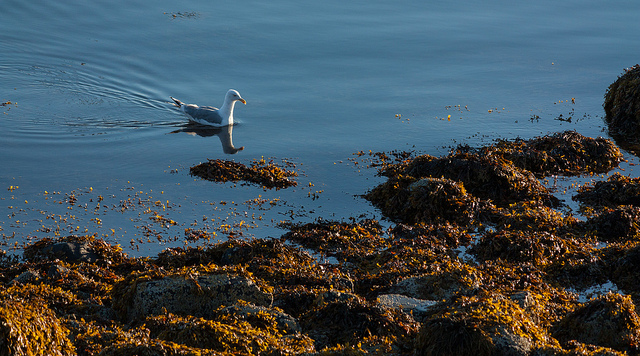What time of day does this scene appear to be? The scene depicted in the image seems to be set in the early morning or late afternoon hours, as indicated by the soft golden light casting long shadows and providing a warm glow, typical of the hours around sunrise or sunset. 